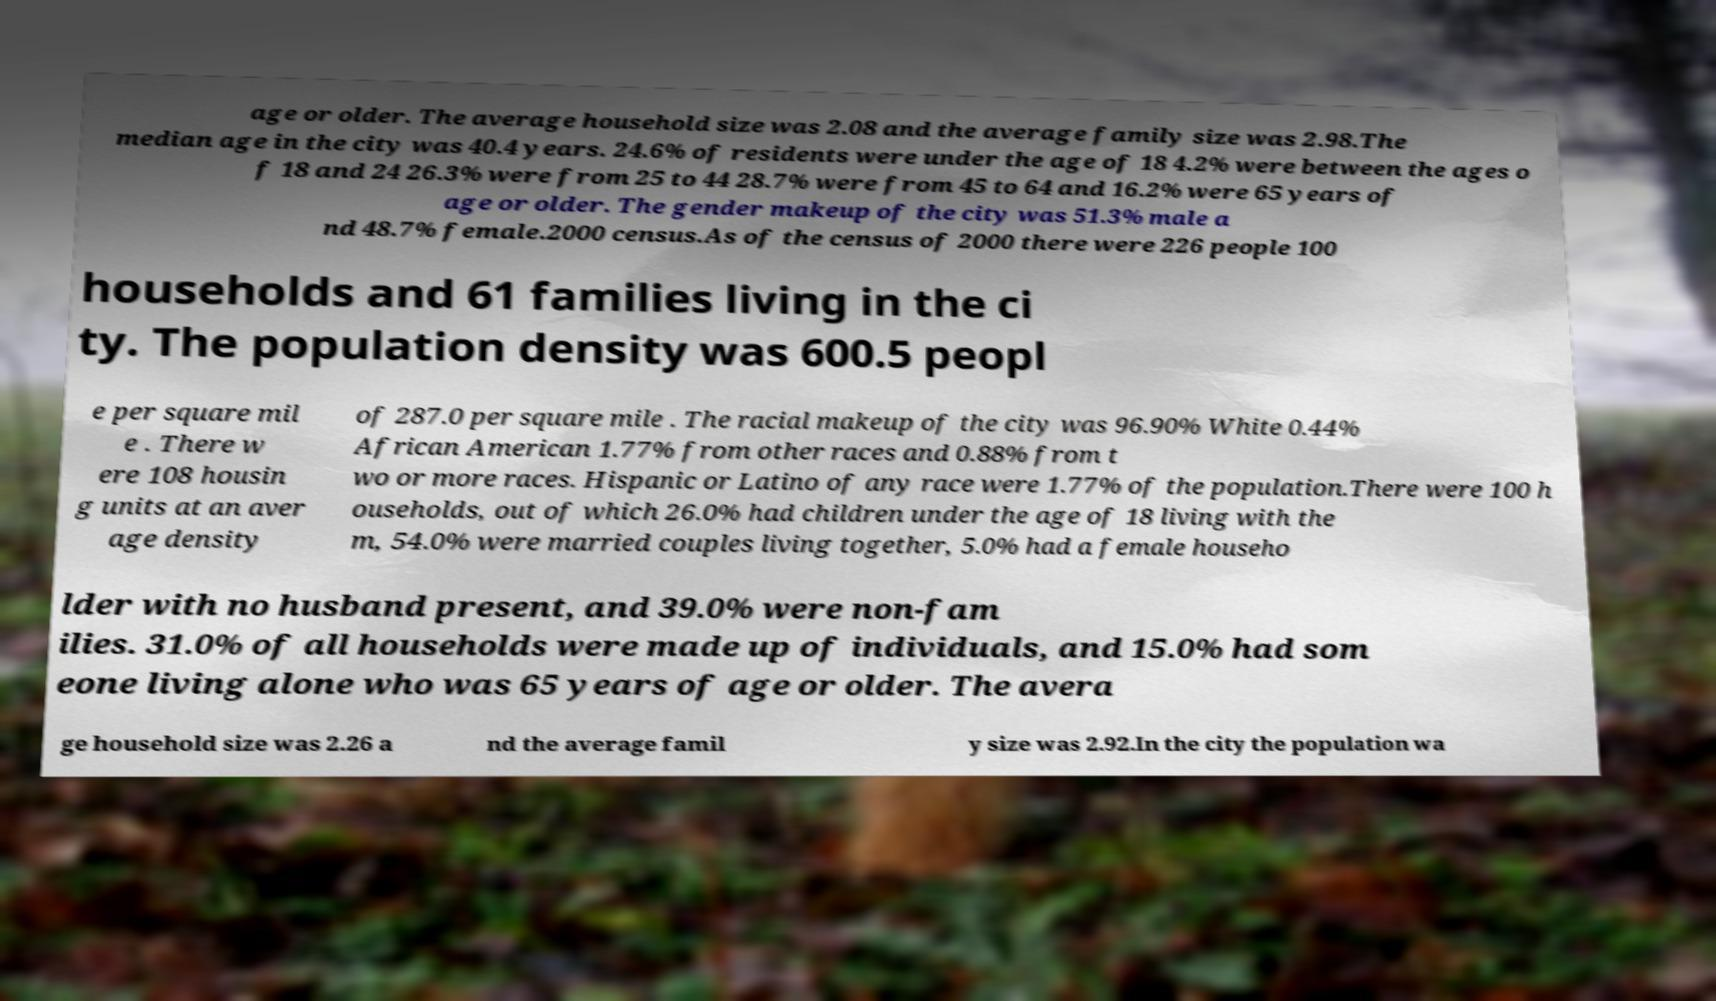Could you assist in decoding the text presented in this image and type it out clearly? age or older. The average household size was 2.08 and the average family size was 2.98.The median age in the city was 40.4 years. 24.6% of residents were under the age of 18 4.2% were between the ages o f 18 and 24 26.3% were from 25 to 44 28.7% were from 45 to 64 and 16.2% were 65 years of age or older. The gender makeup of the city was 51.3% male a nd 48.7% female.2000 census.As of the census of 2000 there were 226 people 100 households and 61 families living in the ci ty. The population density was 600.5 peopl e per square mil e . There w ere 108 housin g units at an aver age density of 287.0 per square mile . The racial makeup of the city was 96.90% White 0.44% African American 1.77% from other races and 0.88% from t wo or more races. Hispanic or Latino of any race were 1.77% of the population.There were 100 h ouseholds, out of which 26.0% had children under the age of 18 living with the m, 54.0% were married couples living together, 5.0% had a female househo lder with no husband present, and 39.0% were non-fam ilies. 31.0% of all households were made up of individuals, and 15.0% had som eone living alone who was 65 years of age or older. The avera ge household size was 2.26 a nd the average famil y size was 2.92.In the city the population wa 